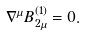<formula> <loc_0><loc_0><loc_500><loc_500>\nabla ^ { \mu } B _ { 2 \mu } ^ { ( 1 ) } = 0 .</formula> 